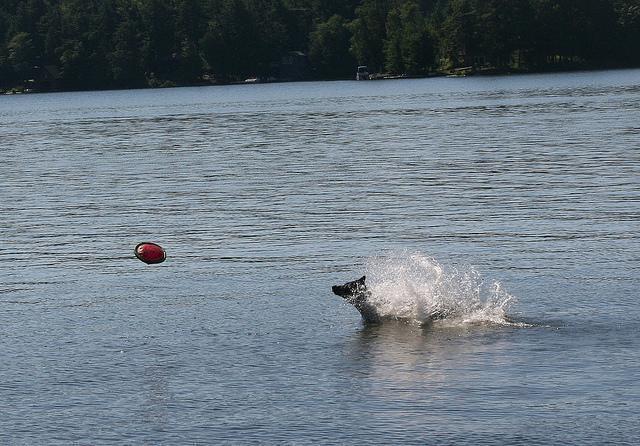How many dogs can you see?
Give a very brief answer. 1. How many knives on the table?
Give a very brief answer. 0. 